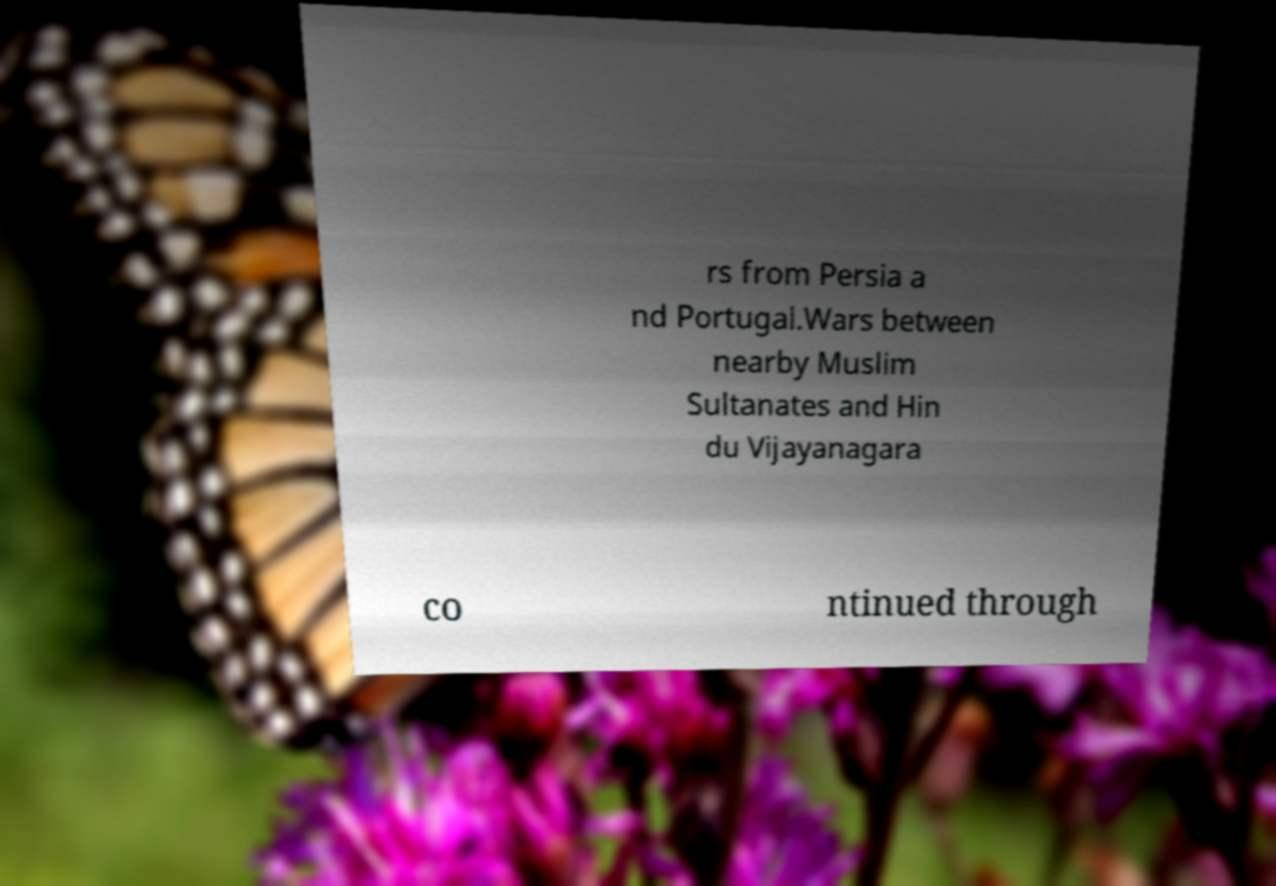Could you assist in decoding the text presented in this image and type it out clearly? rs from Persia a nd Portugal.Wars between nearby Muslim Sultanates and Hin du Vijayanagara co ntinued through 